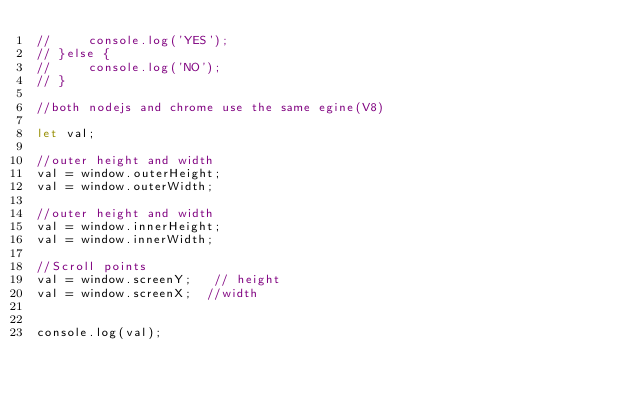<code> <loc_0><loc_0><loc_500><loc_500><_JavaScript_>//     console.log('YES');
// }else {
//     console.log('NO');
// }

//both nodejs and chrome use the same egine(V8)

let val;

//outer height and width
val = window.outerHeight;
val = window.outerWidth;

//outer height and width
val = window.innerHeight;
val = window.innerWidth;

//Scroll points
val = window.screenY;   // height
val = window.screenX;  //width


console.log(val);</code> 